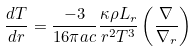<formula> <loc_0><loc_0><loc_500><loc_500>\frac { d T } { d r } = \frac { - 3 } { 1 6 \pi a c } \frac { \kappa \rho L _ { r } } { r ^ { 2 } T ^ { 3 } } \left ( \frac { \nabla } { \nabla _ { r } } \right )</formula> 